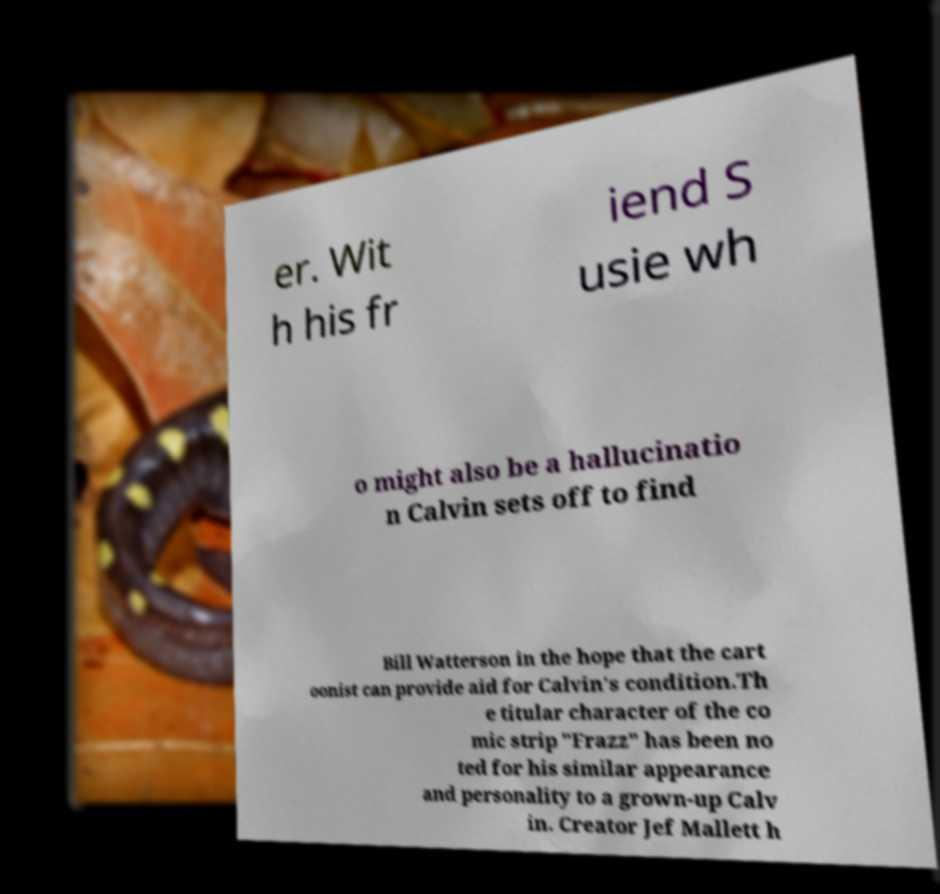For documentation purposes, I need the text within this image transcribed. Could you provide that? er. Wit h his fr iend S usie wh o might also be a hallucinatio n Calvin sets off to find Bill Watterson in the hope that the cart oonist can provide aid for Calvin's condition.Th e titular character of the co mic strip "Frazz" has been no ted for his similar appearance and personality to a grown-up Calv in. Creator Jef Mallett h 